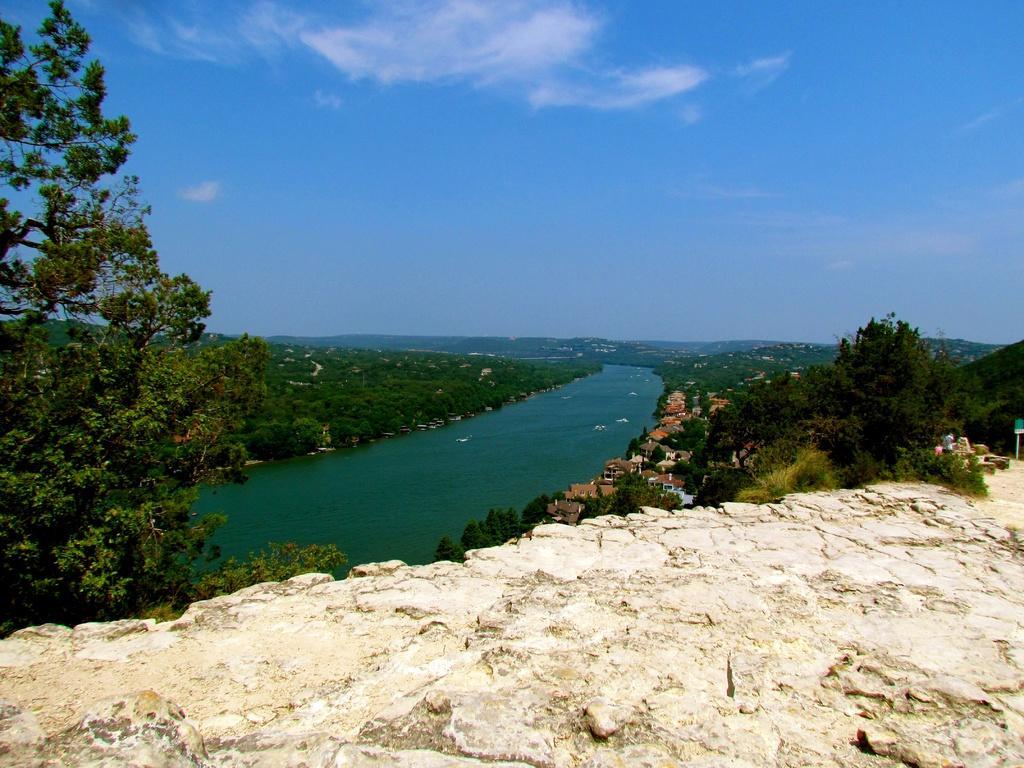In one or two sentences, can you explain what this image depicts? In the image there is a huge stone, around that there is a water surface and trees and houses. 